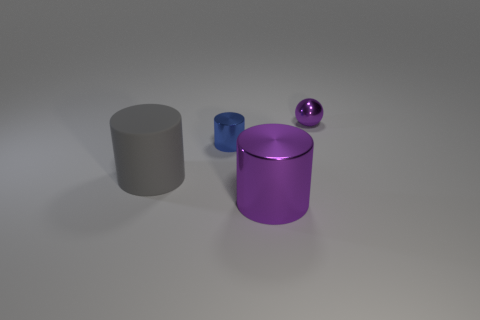Subtract all large cylinders. How many cylinders are left? 1 Add 1 tiny purple matte blocks. How many objects exist? 5 Subtract all cylinders. How many objects are left? 1 Add 2 big matte things. How many big matte things are left? 3 Add 3 tiny purple metal cylinders. How many tiny purple metal cylinders exist? 3 Subtract 0 green spheres. How many objects are left? 4 Subtract all brown balls. Subtract all tiny spheres. How many objects are left? 3 